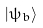<formula> <loc_0><loc_0><loc_500><loc_500>| \psi _ { b } \rangle</formula> 